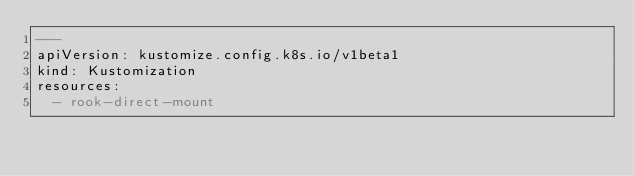Convert code to text. <code><loc_0><loc_0><loc_500><loc_500><_YAML_>---
apiVersion: kustomize.config.k8s.io/v1beta1
kind: Kustomization
resources:
  - rook-direct-mount
</code> 